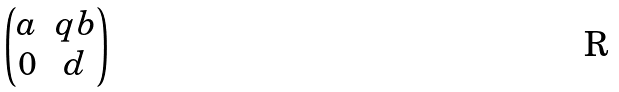Convert formula to latex. <formula><loc_0><loc_0><loc_500><loc_500>\begin{pmatrix} a & q b \\ 0 & d \end{pmatrix}</formula> 